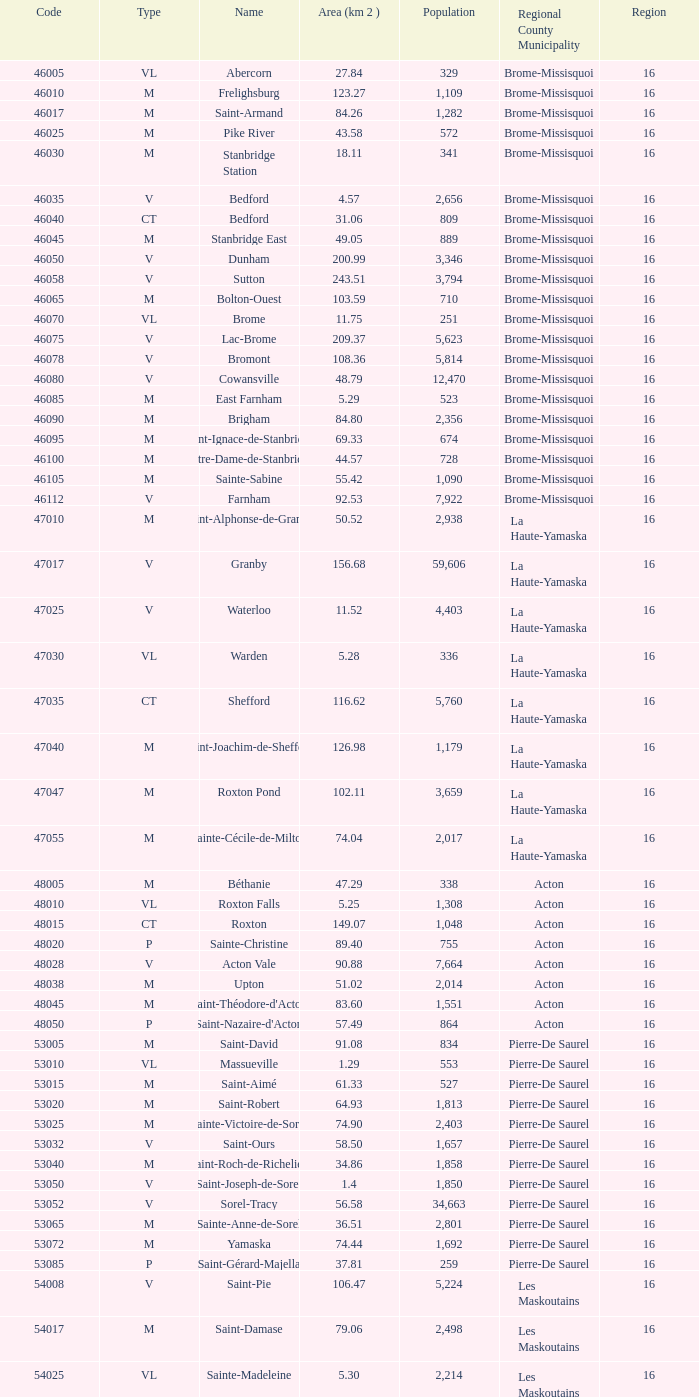Cowansville has less than 16 regions and is a Brome-Missisquoi Municipality, what is their population? None. Can you give me this table as a dict? {'header': ['Code', 'Type', 'Name', 'Area (km 2 )', 'Population', 'Regional County Municipality', 'Region'], 'rows': [['46005', 'VL', 'Abercorn', '27.84', '329', 'Brome-Missisquoi', '16'], ['46010', 'M', 'Frelighsburg', '123.27', '1,109', 'Brome-Missisquoi', '16'], ['46017', 'M', 'Saint-Armand', '84.26', '1,282', 'Brome-Missisquoi', '16'], ['46025', 'M', 'Pike River', '43.58', '572', 'Brome-Missisquoi', '16'], ['46030', 'M', 'Stanbridge Station', '18.11', '341', 'Brome-Missisquoi', '16'], ['46035', 'V', 'Bedford', '4.57', '2,656', 'Brome-Missisquoi', '16'], ['46040', 'CT', 'Bedford', '31.06', '809', 'Brome-Missisquoi', '16'], ['46045', 'M', 'Stanbridge East', '49.05', '889', 'Brome-Missisquoi', '16'], ['46050', 'V', 'Dunham', '200.99', '3,346', 'Brome-Missisquoi', '16'], ['46058', 'V', 'Sutton', '243.51', '3,794', 'Brome-Missisquoi', '16'], ['46065', 'M', 'Bolton-Ouest', '103.59', '710', 'Brome-Missisquoi', '16'], ['46070', 'VL', 'Brome', '11.75', '251', 'Brome-Missisquoi', '16'], ['46075', 'V', 'Lac-Brome', '209.37', '5,623', 'Brome-Missisquoi', '16'], ['46078', 'V', 'Bromont', '108.36', '5,814', 'Brome-Missisquoi', '16'], ['46080', 'V', 'Cowansville', '48.79', '12,470', 'Brome-Missisquoi', '16'], ['46085', 'M', 'East Farnham', '5.29', '523', 'Brome-Missisquoi', '16'], ['46090', 'M', 'Brigham', '84.80', '2,356', 'Brome-Missisquoi', '16'], ['46095', 'M', 'Saint-Ignace-de-Stanbridge', '69.33', '674', 'Brome-Missisquoi', '16'], ['46100', 'M', 'Notre-Dame-de-Stanbridge', '44.57', '728', 'Brome-Missisquoi', '16'], ['46105', 'M', 'Sainte-Sabine', '55.42', '1,090', 'Brome-Missisquoi', '16'], ['46112', 'V', 'Farnham', '92.53', '7,922', 'Brome-Missisquoi', '16'], ['47010', 'M', 'Saint-Alphonse-de-Granby', '50.52', '2,938', 'La Haute-Yamaska', '16'], ['47017', 'V', 'Granby', '156.68', '59,606', 'La Haute-Yamaska', '16'], ['47025', 'V', 'Waterloo', '11.52', '4,403', 'La Haute-Yamaska', '16'], ['47030', 'VL', 'Warden', '5.28', '336', 'La Haute-Yamaska', '16'], ['47035', 'CT', 'Shefford', '116.62', '5,760', 'La Haute-Yamaska', '16'], ['47040', 'M', 'Saint-Joachim-de-Shefford', '126.98', '1,179', 'La Haute-Yamaska', '16'], ['47047', 'M', 'Roxton Pond', '102.11', '3,659', 'La Haute-Yamaska', '16'], ['47055', 'M', 'Sainte-Cécile-de-Milton', '74.04', '2,017', 'La Haute-Yamaska', '16'], ['48005', 'M', 'Béthanie', '47.29', '338', 'Acton', '16'], ['48010', 'VL', 'Roxton Falls', '5.25', '1,308', 'Acton', '16'], ['48015', 'CT', 'Roxton', '149.07', '1,048', 'Acton', '16'], ['48020', 'P', 'Sainte-Christine', '89.40', '755', 'Acton', '16'], ['48028', 'V', 'Acton Vale', '90.88', '7,664', 'Acton', '16'], ['48038', 'M', 'Upton', '51.02', '2,014', 'Acton', '16'], ['48045', 'M', "Saint-Théodore-d'Acton", '83.60', '1,551', 'Acton', '16'], ['48050', 'P', "Saint-Nazaire-d'Acton", '57.49', '864', 'Acton', '16'], ['53005', 'M', 'Saint-David', '91.08', '834', 'Pierre-De Saurel', '16'], ['53010', 'VL', 'Massueville', '1.29', '553', 'Pierre-De Saurel', '16'], ['53015', 'M', 'Saint-Aimé', '61.33', '527', 'Pierre-De Saurel', '16'], ['53020', 'M', 'Saint-Robert', '64.93', '1,813', 'Pierre-De Saurel', '16'], ['53025', 'M', 'Sainte-Victoire-de-Sorel', '74.90', '2,403', 'Pierre-De Saurel', '16'], ['53032', 'V', 'Saint-Ours', '58.50', '1,657', 'Pierre-De Saurel', '16'], ['53040', 'M', 'Saint-Roch-de-Richelieu', '34.86', '1,858', 'Pierre-De Saurel', '16'], ['53050', 'V', 'Saint-Joseph-de-Sorel', '1.4', '1,850', 'Pierre-De Saurel', '16'], ['53052', 'V', 'Sorel-Tracy', '56.58', '34,663', 'Pierre-De Saurel', '16'], ['53065', 'M', 'Sainte-Anne-de-Sorel', '36.51', '2,801', 'Pierre-De Saurel', '16'], ['53072', 'M', 'Yamaska', '74.44', '1,692', 'Pierre-De Saurel', '16'], ['53085', 'P', 'Saint-Gérard-Majella', '37.81', '259', 'Pierre-De Saurel', '16'], ['54008', 'V', 'Saint-Pie', '106.47', '5,224', 'Les Maskoutains', '16'], ['54017', 'M', 'Saint-Damase', '79.06', '2,498', 'Les Maskoutains', '16'], ['54025', 'VL', 'Sainte-Madeleine', '5.30', '2,214', 'Les Maskoutains', '16'], ['54030', 'P', 'Sainte-Marie-Madeleine', '49.53', '2,713', 'Les Maskoutains', '16'], ['54035', 'M', 'La Présentation', '104.71', '2,078', 'Les Maskoutains', '16'], ['54048', 'V', 'Saint-Hyacinthe', '189.11', '51,984', 'Les Maskoutains', '16'], ['54060', 'M', 'Saint-Dominique', '70.16', '2,308', 'Les Maskoutains', '16'], ['54065', 'M', 'Saint-Valérien-de-Milton', '106.44', '1,785', 'Les Maskoutains', '16'], ['54072', 'M', 'Saint-Liboire', '72.90', '2,846', 'Les Maskoutains', '16'], ['54090', 'M', 'Saint-Simon', '68.66', '1,136', 'Les Maskoutains', '16'], ['54095', 'M', 'Sainte-Hélène-de-Bagot', '73.53', '1,541', 'Les Maskoutains', '16'], ['54100', 'M', 'Saint-Hugues', '89.30', '1,420', 'Les Maskoutains', '16'], ['54105', 'M', 'Saint-Barnabé-Sud', '57.08', '881', 'Les Maskoutains', '16'], ['54110', 'M', 'Saint-Jude', '77.36', '1,111', 'Les Maskoutains', '16'], ['54115', 'M', 'Saint-Bernard-de-Michaudville', '64.80', '581', 'Les Maskoutains', '16'], ['54120', 'M', 'Saint-Louis', '45.92', '752', 'Les Maskoutains', '16'], ['54125', 'M', 'Saint-Marcel-de-Richelieu', '50.21', '613', 'Les Maskoutains', '16'], ['55008', 'M', 'Ange-Gardien', '89.07', '1,994', 'Rouville', '16'], ['55015', 'M', "Saint-Paul-d'Abbotsford", '79.59', '2,910', 'Rouville', '16'], ['55023', 'V', 'Saint-Césaire', '84.14', '5,039', 'Rouville', '16'], ['55030', 'M', 'Sainte-Angèle-de-Monnoir', '45.49', '1,474', 'Rouville', '16'], ['55037', 'M', 'Rougemont', '44.48', '2,631', 'Rouville', '16'], ['55048', 'V', 'Marieville', '64.25', '7,377', 'Rouville', '16'], ['55057', 'V', 'Richelieu', '29.75', '5,658', 'Rouville', '16'], ['55065', 'M', 'Saint-Mathias-sur-Richelieu', '48.22', '4,453', 'Rouville', '16'], ['56005', 'M', 'Venise-en-Québec', '13.57', '1,414', 'Le Haut-Richelieu', '16'], ['56010', 'M', 'Saint-Georges-de-Clarenceville', '63.76', '1,170', 'Le Haut-Richelieu', '16'], ['56015', 'M', 'Noyan', '43.79', '1,192', 'Le Haut-Richelieu', '16'], ['56023', 'M', 'Lacolle', '49.17', '2,502', 'Le Haut-Richelieu', '16'], ['56030', 'M', 'Saint-Valentin', '40.09', '527', 'Le Haut-Richelieu', '16'], ['56035', 'M', "Saint-Paul-de-l'Île-aux-Noix", '29.47', '2,049', 'Le Haut-Richelieu', '16'], ['56042', 'M', 'Henryville', '64.87', '1,520', 'Le Haut-Richelieu', '16'], ['56050', 'M', 'Saint-Sébastien', '62.65', '759', 'Le Haut-Richelieu', '16'], ['56055', 'M', 'Saint-Alexandre', '76.55', '2,517', 'Le Haut-Richelieu', '16'], ['56060', 'P', 'Sainte-Anne-de-Sabrevois', '45.24', '1,964', 'Le Haut-Richelieu', '16'], ['56065', 'M', 'Saint-Blaise-sur-Richelieu', '68.42', '2,040', 'Le Haut-Richelieu', '16'], ['56083', 'V', 'Saint-Jean-sur-Richelieu', '225.61', '86,802', 'Le Haut-Richelieu', '16'], ['56097', 'M', 'Mont-Saint-Grégoire', '79.92', '3,077', 'Le Haut-Richelieu', '16'], ['56105', 'M', "Sainte-Brigide-d'Iberville", '68.89', '1,260', 'Le Haut-Richelieu', '16'], ['57005', 'V', 'Chambly', '25.01', '22,332', 'La Vallée-du-Richelieu', '16'], ['57010', 'V', 'Carignan', '62.39', '6,911', 'La Vallée-du-Richelieu', '16'], ['57020', 'V', 'Saint-Basile-le-Grand', '34.82', '15,100', 'La Vallée-du-Richelieu', '16'], ['57025', 'M', 'McMasterville', '3.00', '4,773', 'La Vallée-du-Richelieu', '16'], ['57030', 'V', 'Otterburn Park', '5.20', '8,696', 'La Vallée-du-Richelieu', '16'], ['57033', 'M', 'Saint-Jean-Baptiste', '75.98', '2,875', 'La Vallée-du-Richelieu', '16'], ['57035', 'V', 'Mont-Saint-Hilaire', '38.96', '15,820', 'La Vallée-du-Richelieu', '16'], ['57040', 'V', 'Beloeil', '24.00', '19,428', 'La Vallée-du-Richelieu', '16'], ['57045', 'M', 'Saint-Mathieu-de-Beloeil', '39.26', '2,381', 'La Vallée-du-Richelieu', '16'], ['57050', 'M', 'Saint-Marc-sur-Richelieu', '59.51', '1,992', 'La Vallée-du-Richelieu', '16'], ['57057', 'M', 'Saint-Charles-sur-Richelieu', '63.59', '1,808', 'La Vallée-du-Richelieu', '16'], ['57068', 'M', 'Saint-Denis-sur-Richelieu', '82.20', '2,272', 'La Vallée-du-Richelieu', '16'], ['57075', 'M', 'Saint-Antoine-sur-Richelieu', '65.26', '1,571', 'La Vallée-du-Richelieu', '16'], ['58007', 'V', 'Brossard', '44.77', '71,372', 'Not part of a RCM', '16'], ['58012', 'V', 'Saint-Lambert', '6.43', '21,772', 'Not part of a RCM', '16'], ['58033', 'V', 'Boucherville', '69.33', '38,526', 'Not part of a RCM', '16'], ['58037', 'V', 'Saint-Bruno-de-Montarville', '41.89', '24,571', 'Not part of a RCM', '16'], ['58227', 'V', 'Longueuil', '111.50', '231,969', 'Not part of a RCM', '16'], ['59010', 'V', 'Sainte-Julie', '47.78', '29,000', "Marguerite-D'Youville", '16'], ['59015', 'M', 'Saint-Amable', '38.04', '8,135', "Marguerite-D'Youville", '16'], ['59020', 'V', 'Varennes', '93.96', '20,608', "Marguerite-D'Youville", '16'], ['59025', 'M', 'Verchères', '72.77', '5,103', "Marguerite-D'Youville", '16'], ['59030', 'P', 'Calixa-Lavallée', '32.42', '517', "Marguerite-D'Youville", '16'], ['59035', 'V', 'Contrecœur', '61.56', '5,603', "Marguerite-D'Youville", '16'], ['67005', 'M', 'Saint-Mathieu', '32.27', '2,032', 'Roussillon', '16'], ['67010', 'M', 'Saint-Philippe', '61.66', '4,763', 'Roussillon', '16'], ['67015', 'V', 'La Prairie', '43.53', '21,609', 'Roussillon', '16'], ['67020', 'V', 'Candiac', '16.40', '14,866', 'Roussillon', '16'], ['67025', 'V', 'Delson', '7.76', '7,382', 'Roussillon', '16'], ['67030', 'V', 'Sainte-Catherine', '9.06', '16,770', 'Roussillon', '16'], ['67035', 'V', 'Saint-Constant', '56.58', '24,679', 'Roussillon', '16'], ['67040', 'P', 'Saint-Isidore', '52.00', '2,476', 'Roussillon', '16'], ['67045', 'V', 'Mercier', '45.89', '10,231', 'Roussillon', '16'], ['67050', 'V', 'Châteauguay', '35.37', '43,178', 'Roussillon', '16'], ['67055', 'V', 'Léry', '10.98', '2,368', 'Roussillon', '16'], ['68005', 'P', 'Saint-Bernard-de-Lacolle', '112.63', '1,601', 'Les Jardins-de-Napierville', '16'], ['68010', 'VL', 'Hemmingford', '0.85', '737', 'Les Jardins-de-Napierville', '16'], ['68015', 'CT', 'Hemmingford', '155.78', '1,735', 'Les Jardins-de-Napierville', '16'], ['68020', 'M', 'Sainte-Clotilde', '78.96', '1,593', 'Les Jardins-de-Napierville', '16'], ['68025', 'M', 'Saint-Patrice-de-Sherrington', '91.47', '1,946', 'Les Jardins-de-Napierville', '16'], ['68030', 'M', 'Napierville', '4.53', '3,310', 'Les Jardins-de-Napierville', '16'], ['68035', 'M', 'Saint-Cyprien-de-Napierville', '97.62', '1,414', 'Les Jardins-de-Napierville', '16'], ['68040', 'M', 'Saint-Jacques-le-Mineur', '65.19', '1,670', 'Les Jardins-de-Napierville', '16'], ['68045', 'M', 'Saint-Édouard', '52.91', '1,226', 'Les Jardins-de-Napierville', '16'], ['68050', 'M', 'Saint-Michel', '57.36', '2,681', 'Les Jardins-de-Napierville', '16'], ['68055', 'V', 'Saint-Rémi', '79.66', '6,089', 'Les Jardins-de-Napierville', '16'], ['69005', 'CT', 'Havelock', '87.98', '853', 'Le Haut-Saint-Laurent', '16'], ['69010', 'M', 'Franklin', '112.19', '1,601', 'Le Haut-Saint-Laurent', '16'], ['69017', 'M', 'Saint-Chrysostome', '99.54', '2,689', 'Le Haut-Saint-Laurent', '16'], ['69025', 'M', 'Howick', '0.89', '589', 'Le Haut-Saint-Laurent', '16'], ['69030', 'P', 'Très-Saint-Sacrement', '97.30', '1,250', 'Le Haut-Saint-Laurent', '16'], ['69037', 'M', 'Ormstown', '142.39', '3,742', 'Le Haut-Saint-Laurent', '16'], ['69045', 'M', 'Hinchinbrooke', '148.95', '2,425', 'Le Haut-Saint-Laurent', '16'], ['69050', 'M', 'Elgin', '69.38', '463', 'Le Haut-Saint-Laurent', '16'], ['69055', 'V', 'Huntingdon', '2.58', '2,695', 'Le Haut-Saint-Laurent', '16'], ['69060', 'CT', 'Godmanchester', '138.77', '1,512', 'Le Haut-Saint-Laurent', '16'], ['69065', 'M', 'Sainte-Barbe', '39.78', '1,407', 'Le Haut-Saint-Laurent', '16'], ['69070', 'M', 'Saint-Anicet', '136.25', '2,736', 'Le Haut-Saint-Laurent', '16'], ['69075', 'CT', 'Dundee', '94.20', '406', 'Le Haut-Saint-Laurent', '16'], ['70005', 'M', 'Saint-Urbain-Premier', '52.24', '1,181', 'Beauharnois-Salaberry', '16'], ['70012', 'M', 'Sainte-Martine', '59.79', '4,037', 'Beauharnois-Salaberry', '16'], ['70022', 'V', 'Beauharnois', '73.05', '12,041', 'Beauharnois-Salaberry', '16'], ['70030', 'M', 'Saint-Étienne-de-Beauharnois', '41.62', '738', 'Beauharnois-Salaberry', '16'], ['70035', 'P', 'Saint-Louis-de-Gonzague', '78.52', '1,402', 'Beauharnois-Salaberry', '16'], ['70040', 'M', 'Saint-Stanislas-de-Kostka', '62.16', '1,653', 'Beauharnois-Salaberry', '16'], ['70052', 'V', 'Salaberry-de-Valleyfield', '100.96', '40,056', 'Beauharnois-Salaberry', '16'], ['71005', 'M', 'Rivière-Beaudette', '19.62', '1,701', 'Vaudreuil-Soulanges', '16'], ['71015', 'M', 'Saint-Télesphore', '59.62', '777', 'Vaudreuil-Soulanges', '16'], ['71020', 'M', 'Saint-Polycarpe', '70.80', '1,737', 'Vaudreuil-Soulanges', '16'], ['71025', 'M', 'Saint-Zotique', '24.24', '4,947', 'Vaudreuil-Soulanges', '16'], ['71033', 'M', 'Les Coteaux', '12.11', '3,684', 'Vaudreuil-Soulanges', '16'], ['71040', 'V', 'Coteau-du-Lac', '46.57', '6,458', 'Vaudreuil-Soulanges', '16'], ['71045', 'M', 'Saint-Clet', '38.61', '1,663', 'Vaudreuil-Soulanges', '16'], ['71050', 'M', 'Les Cèdres', '78.31', '5,842', 'Vaudreuil-Soulanges', '16'], ['71055', 'VL', 'Pointe-des-Cascades', '2.66', '1,014', 'Vaudreuil-Soulanges', '16'], ['71060', 'V', "L'Île-Perrot", '4.86', '10,131', 'Vaudreuil-Soulanges', '16'], ['71065', 'V', "Notre-Dame-de-l'Île-Perrot", '28.14', '9,783', 'Vaudreuil-Soulanges', '16'], ['71070', 'V', 'Pincourt', '8.36', '10,960', 'Vaudreuil-Soulanges', '16'], ['71075', 'M', 'Terrasse-Vaudreuil', '1.08', '2,086', 'Vaudreuil-Soulanges', '16'], ['71083', 'V', 'Vaudreuil-Dorion', '73.18', '24,589', 'Vaudreuil-Soulanges', '16'], ['71090', 'VL', 'Vaudreuil-sur-le-Lac', '1.73', '1,058', 'Vaudreuil-Soulanges', '16'], ['71095', 'V', "L'Île-Cadieux", '0.62', '141', 'Vaudreuil-Soulanges', '16'], ['71100', 'V', 'Hudson', '21.62', '5,193', 'Vaudreuil-Soulanges', '16'], ['71105', 'V', 'Saint-Lazare', '67.59', '15,954', 'Vaudreuil-Soulanges', '16'], ['71110', 'M', 'Sainte-Marthe', '80.23', '1,142', 'Vaudreuil-Soulanges', '16'], ['71115', 'M', 'Sainte-Justine-de-Newton', '84.14', '968', 'Vaudreuil-Soulanges', '16'], ['71125', 'M', 'Très-Saint-Rédempteur', '25.40', '645', 'Vaudreuil-Soulanges', '16'], ['71133', 'M', 'Rigaud', '97.15', '6,724', 'Vaudreuil-Soulanges', '16'], ['71140', 'VL', 'Pointe-Fortune', '9.09', '512', 'Vaudreuil-Soulanges', '16']]} 